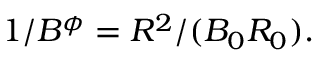Convert formula to latex. <formula><loc_0><loc_0><loc_500><loc_500>1 / B ^ { \phi } = R ^ { 2 } / ( B _ { 0 } R _ { 0 } ) .</formula> 